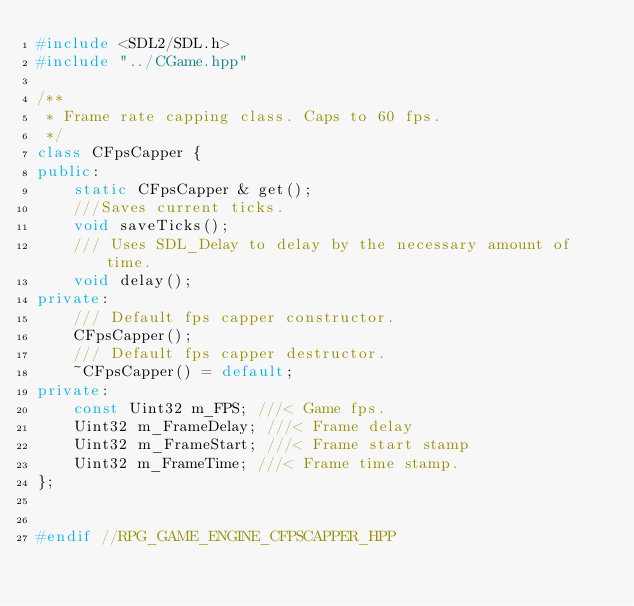Convert code to text. <code><loc_0><loc_0><loc_500><loc_500><_C++_>#include <SDL2/SDL.h>
#include "../CGame.hpp"

/**
 * Frame rate capping class. Caps to 60 fps.
 */
class CFpsCapper {
public:
    static CFpsCapper & get();
    ///Saves current ticks.
    void saveTicks();
    /// Uses SDL_Delay to delay by the necessary amount of time.
    void delay();
private:
    /// Default fps capper constructor.
    CFpsCapper();
    /// Default fps capper destructor.
    ~CFpsCapper() = default;
private:
    const Uint32 m_FPS; ///< Game fps.
    Uint32 m_FrameDelay; ///< Frame delay
    Uint32 m_FrameStart; ///< Frame start stamp
    Uint32 m_FrameTime; ///< Frame time stamp.
};


#endif //RPG_GAME_ENGINE_CFPSCAPPER_HPP
</code> 